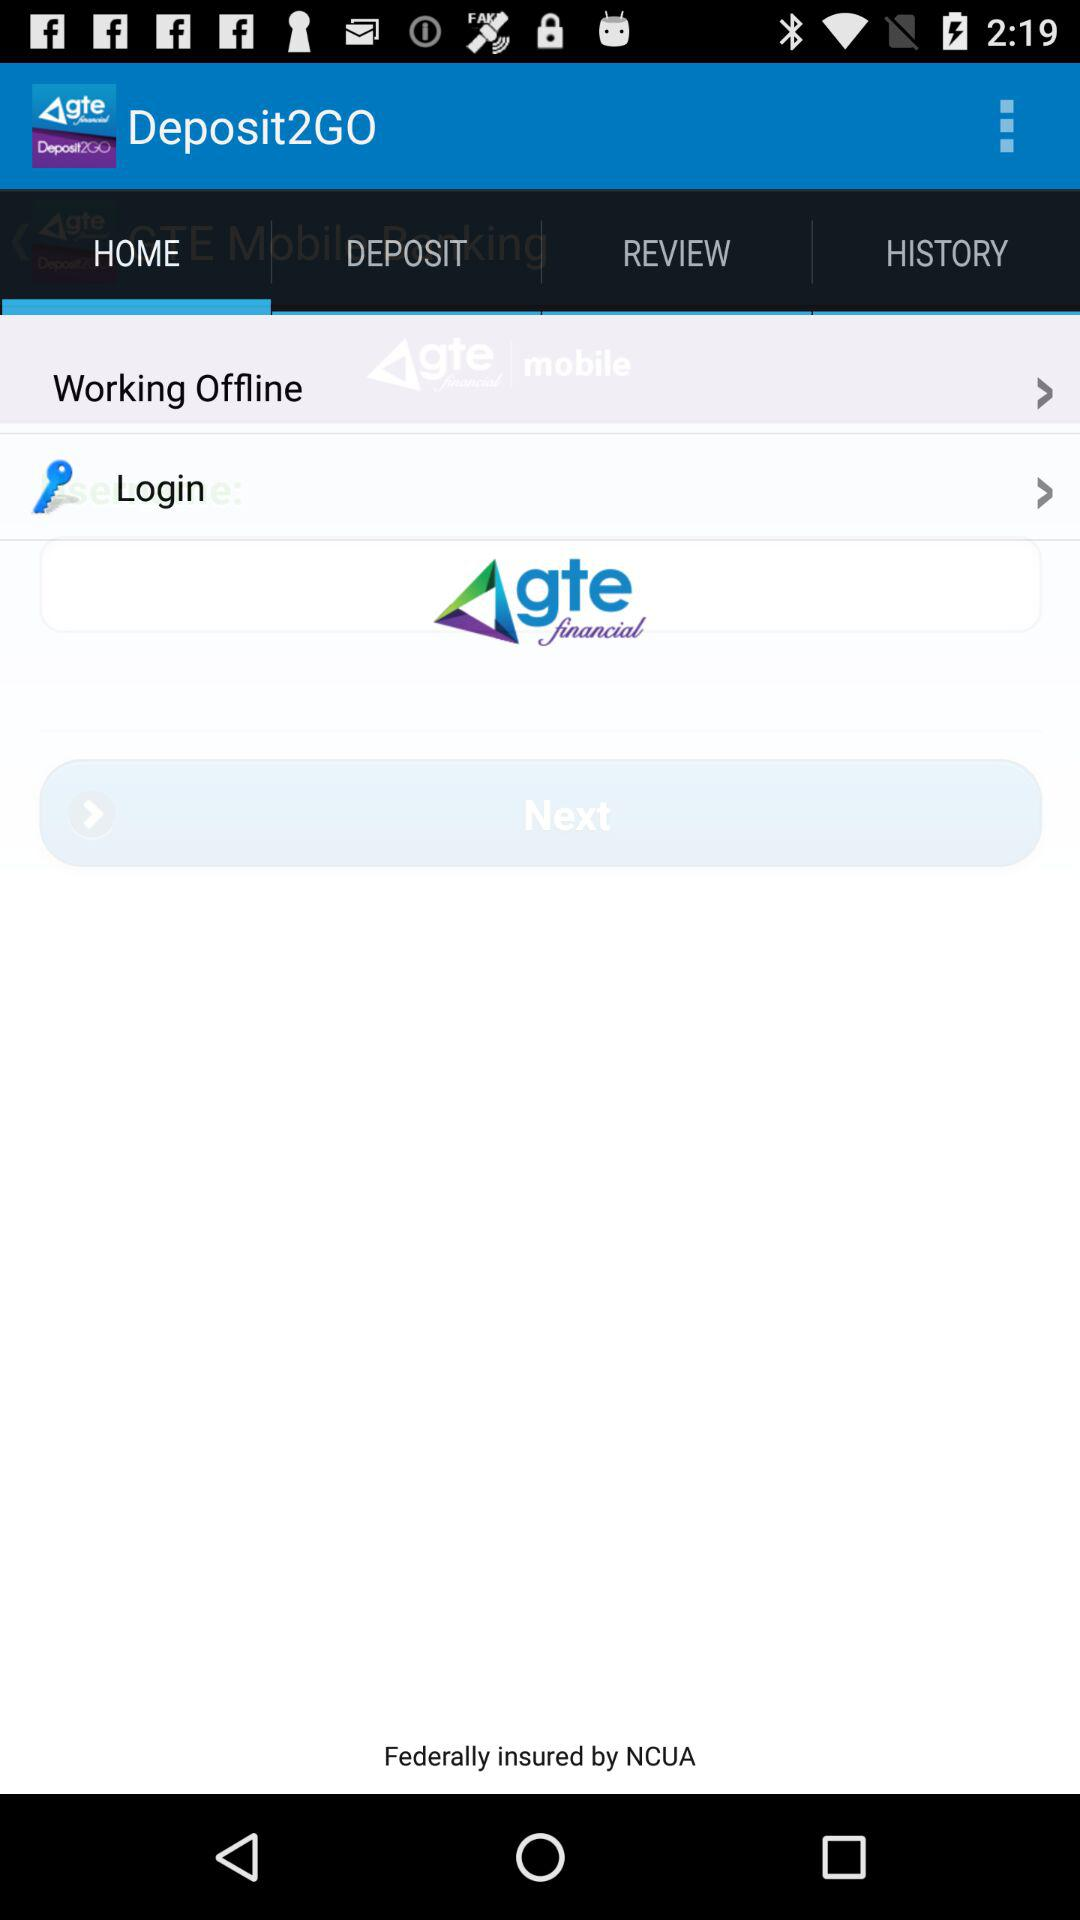Which tab is selected? The selected tab is "HOME". 